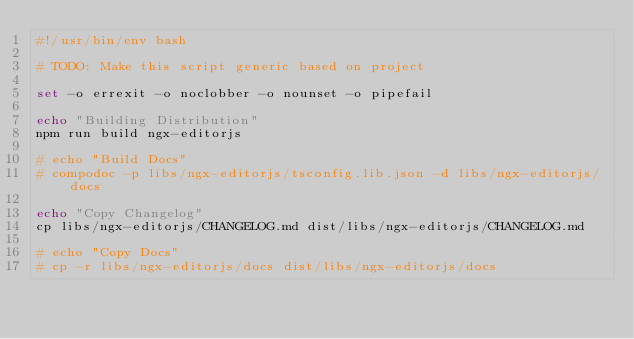<code> <loc_0><loc_0><loc_500><loc_500><_Bash_>#!/usr/bin/env bash

# TODO: Make this script generic based on project

set -o errexit -o noclobber -o nounset -o pipefail

echo "Building Distribution"
npm run build ngx-editorjs

# echo "Build Docs"
# compodoc -p libs/ngx-editorjs/tsconfig.lib.json -d libs/ngx-editorjs/docs

echo "Copy Changelog"
cp libs/ngx-editorjs/CHANGELOG.md dist/libs/ngx-editorjs/CHANGELOG.md

# echo "Copy Docs"
# cp -r libs/ngx-editorjs/docs dist/libs/ngx-editorjs/docs
</code> 